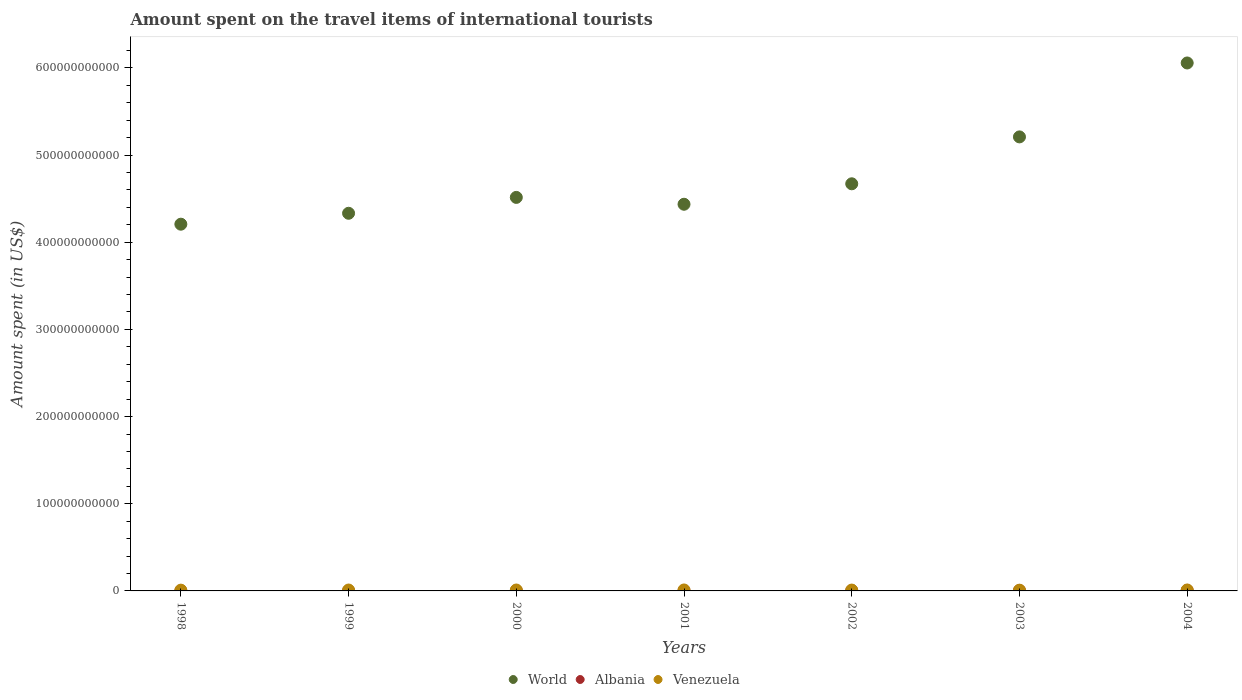Is the number of dotlines equal to the number of legend labels?
Your answer should be compact. Yes. What is the amount spent on the travel items of international tourists in Venezuela in 2000?
Provide a succinct answer. 1.06e+09. Across all years, what is the maximum amount spent on the travel items of international tourists in Venezuela?
Provide a succinct answer. 1.11e+09. Across all years, what is the minimum amount spent on the travel items of international tourists in Venezuela?
Provide a short and direct response. 8.59e+08. In which year was the amount spent on the travel items of international tourists in Venezuela minimum?
Your answer should be very brief. 2003. What is the total amount spent on the travel items of international tourists in World in the graph?
Provide a short and direct response. 3.34e+12. What is the difference between the amount spent on the travel items of international tourists in Albania in 1998 and that in 2001?
Give a very brief answer. -2.52e+08. What is the difference between the amount spent on the travel items of international tourists in Albania in 1998 and the amount spent on the travel items of international tourists in World in 2004?
Make the answer very short. -6.06e+11. What is the average amount spent on the travel items of international tourists in World per year?
Ensure brevity in your answer.  4.77e+11. In the year 2003, what is the difference between the amount spent on the travel items of international tourists in Albania and amount spent on the travel items of international tourists in Venezuela?
Your answer should be very brief. -3.70e+08. In how many years, is the amount spent on the travel items of international tourists in Albania greater than 60000000000 US$?
Make the answer very short. 0. What is the ratio of the amount spent on the travel items of international tourists in Albania in 2003 to that in 2004?
Provide a succinct answer. 0.76. Is the amount spent on the travel items of international tourists in Venezuela in 1999 less than that in 2004?
Your answer should be very brief. Yes. What is the difference between the highest and the second highest amount spent on the travel items of international tourists in World?
Your answer should be very brief. 8.48e+1. What is the difference between the highest and the lowest amount spent on the travel items of international tourists in World?
Ensure brevity in your answer.  1.85e+11. Is it the case that in every year, the sum of the amount spent on the travel items of international tourists in World and amount spent on the travel items of international tourists in Venezuela  is greater than the amount spent on the travel items of international tourists in Albania?
Make the answer very short. Yes. Is the amount spent on the travel items of international tourists in World strictly greater than the amount spent on the travel items of international tourists in Venezuela over the years?
Offer a very short reply. Yes. How many dotlines are there?
Keep it short and to the point. 3. How many years are there in the graph?
Provide a succinct answer. 7. What is the difference between two consecutive major ticks on the Y-axis?
Your answer should be compact. 1.00e+11. Are the values on the major ticks of Y-axis written in scientific E-notation?
Offer a very short reply. No. How many legend labels are there?
Offer a terse response. 3. How are the legend labels stacked?
Offer a very short reply. Horizontal. What is the title of the graph?
Offer a terse response. Amount spent on the travel items of international tourists. Does "Thailand" appear as one of the legend labels in the graph?
Offer a terse response. No. What is the label or title of the X-axis?
Your answer should be compact. Years. What is the label or title of the Y-axis?
Ensure brevity in your answer.  Amount spent (in US$). What is the Amount spent (in US$) in World in 1998?
Provide a succinct answer. 4.21e+11. What is the Amount spent (in US$) in Albania in 1998?
Keep it short and to the point. 5.00e+06. What is the Amount spent (in US$) in Venezuela in 1998?
Keep it short and to the point. 8.91e+08. What is the Amount spent (in US$) in World in 1999?
Keep it short and to the point. 4.33e+11. What is the Amount spent (in US$) in Venezuela in 1999?
Provide a short and direct response. 1.04e+09. What is the Amount spent (in US$) in World in 2000?
Ensure brevity in your answer.  4.51e+11. What is the Amount spent (in US$) of Albania in 2000?
Your answer should be compact. 2.72e+08. What is the Amount spent (in US$) of Venezuela in 2000?
Provide a short and direct response. 1.06e+09. What is the Amount spent (in US$) of World in 2001?
Ensure brevity in your answer.  4.44e+11. What is the Amount spent (in US$) in Albania in 2001?
Keep it short and to the point. 2.57e+08. What is the Amount spent (in US$) of Venezuela in 2001?
Make the answer very short. 1.11e+09. What is the Amount spent (in US$) of World in 2002?
Offer a very short reply. 4.67e+11. What is the Amount spent (in US$) of Albania in 2002?
Make the answer very short. 3.65e+08. What is the Amount spent (in US$) of Venezuela in 2002?
Keep it short and to the point. 9.81e+08. What is the Amount spent (in US$) of World in 2003?
Provide a succinct answer. 5.21e+11. What is the Amount spent (in US$) in Albania in 2003?
Provide a short and direct response. 4.89e+08. What is the Amount spent (in US$) of Venezuela in 2003?
Ensure brevity in your answer.  8.59e+08. What is the Amount spent (in US$) in World in 2004?
Give a very brief answer. 6.06e+11. What is the Amount spent (in US$) in Albania in 2004?
Give a very brief answer. 6.42e+08. What is the Amount spent (in US$) in Venezuela in 2004?
Offer a terse response. 1.08e+09. Across all years, what is the maximum Amount spent (in US$) in World?
Offer a terse response. 6.06e+11. Across all years, what is the maximum Amount spent (in US$) in Albania?
Your answer should be very brief. 6.42e+08. Across all years, what is the maximum Amount spent (in US$) of Venezuela?
Offer a very short reply. 1.11e+09. Across all years, what is the minimum Amount spent (in US$) of World?
Offer a very short reply. 4.21e+11. Across all years, what is the minimum Amount spent (in US$) in Venezuela?
Make the answer very short. 8.59e+08. What is the total Amount spent (in US$) of World in the graph?
Provide a succinct answer. 3.34e+12. What is the total Amount spent (in US$) of Albania in the graph?
Keep it short and to the point. 2.04e+09. What is the total Amount spent (in US$) of Venezuela in the graph?
Give a very brief answer. 7.01e+09. What is the difference between the Amount spent (in US$) in World in 1998 and that in 1999?
Provide a succinct answer. -1.25e+1. What is the difference between the Amount spent (in US$) of Albania in 1998 and that in 1999?
Provide a succinct answer. -7.00e+06. What is the difference between the Amount spent (in US$) in Venezuela in 1998 and that in 1999?
Provide a succinct answer. -1.48e+08. What is the difference between the Amount spent (in US$) of World in 1998 and that in 2000?
Give a very brief answer. -3.07e+1. What is the difference between the Amount spent (in US$) of Albania in 1998 and that in 2000?
Your answer should be compact. -2.67e+08. What is the difference between the Amount spent (in US$) in Venezuela in 1998 and that in 2000?
Give a very brief answer. -1.67e+08. What is the difference between the Amount spent (in US$) of World in 1998 and that in 2001?
Make the answer very short. -2.29e+1. What is the difference between the Amount spent (in US$) of Albania in 1998 and that in 2001?
Give a very brief answer. -2.52e+08. What is the difference between the Amount spent (in US$) of Venezuela in 1998 and that in 2001?
Offer a very short reply. -2.17e+08. What is the difference between the Amount spent (in US$) in World in 1998 and that in 2002?
Keep it short and to the point. -4.63e+1. What is the difference between the Amount spent (in US$) of Albania in 1998 and that in 2002?
Your answer should be very brief. -3.60e+08. What is the difference between the Amount spent (in US$) in Venezuela in 1998 and that in 2002?
Your answer should be compact. -9.00e+07. What is the difference between the Amount spent (in US$) of World in 1998 and that in 2003?
Make the answer very short. -1.00e+11. What is the difference between the Amount spent (in US$) of Albania in 1998 and that in 2003?
Your answer should be very brief. -4.84e+08. What is the difference between the Amount spent (in US$) in Venezuela in 1998 and that in 2003?
Give a very brief answer. 3.20e+07. What is the difference between the Amount spent (in US$) of World in 1998 and that in 2004?
Offer a terse response. -1.85e+11. What is the difference between the Amount spent (in US$) in Albania in 1998 and that in 2004?
Your answer should be very brief. -6.37e+08. What is the difference between the Amount spent (in US$) in Venezuela in 1998 and that in 2004?
Your answer should be very brief. -1.86e+08. What is the difference between the Amount spent (in US$) in World in 1999 and that in 2000?
Provide a succinct answer. -1.82e+1. What is the difference between the Amount spent (in US$) of Albania in 1999 and that in 2000?
Give a very brief answer. -2.60e+08. What is the difference between the Amount spent (in US$) in Venezuela in 1999 and that in 2000?
Your answer should be compact. -1.90e+07. What is the difference between the Amount spent (in US$) in World in 1999 and that in 2001?
Keep it short and to the point. -1.04e+1. What is the difference between the Amount spent (in US$) of Albania in 1999 and that in 2001?
Your answer should be compact. -2.45e+08. What is the difference between the Amount spent (in US$) of Venezuela in 1999 and that in 2001?
Provide a succinct answer. -6.90e+07. What is the difference between the Amount spent (in US$) in World in 1999 and that in 2002?
Make the answer very short. -3.38e+1. What is the difference between the Amount spent (in US$) in Albania in 1999 and that in 2002?
Provide a short and direct response. -3.53e+08. What is the difference between the Amount spent (in US$) in Venezuela in 1999 and that in 2002?
Provide a succinct answer. 5.80e+07. What is the difference between the Amount spent (in US$) of World in 1999 and that in 2003?
Your answer should be very brief. -8.76e+1. What is the difference between the Amount spent (in US$) in Albania in 1999 and that in 2003?
Offer a very short reply. -4.77e+08. What is the difference between the Amount spent (in US$) in Venezuela in 1999 and that in 2003?
Your answer should be very brief. 1.80e+08. What is the difference between the Amount spent (in US$) of World in 1999 and that in 2004?
Your response must be concise. -1.72e+11. What is the difference between the Amount spent (in US$) of Albania in 1999 and that in 2004?
Offer a very short reply. -6.30e+08. What is the difference between the Amount spent (in US$) in Venezuela in 1999 and that in 2004?
Your answer should be very brief. -3.80e+07. What is the difference between the Amount spent (in US$) in World in 2000 and that in 2001?
Your response must be concise. 7.86e+09. What is the difference between the Amount spent (in US$) in Albania in 2000 and that in 2001?
Your response must be concise. 1.50e+07. What is the difference between the Amount spent (in US$) in Venezuela in 2000 and that in 2001?
Keep it short and to the point. -5.00e+07. What is the difference between the Amount spent (in US$) in World in 2000 and that in 2002?
Your response must be concise. -1.56e+1. What is the difference between the Amount spent (in US$) in Albania in 2000 and that in 2002?
Offer a terse response. -9.30e+07. What is the difference between the Amount spent (in US$) in Venezuela in 2000 and that in 2002?
Give a very brief answer. 7.70e+07. What is the difference between the Amount spent (in US$) of World in 2000 and that in 2003?
Ensure brevity in your answer.  -6.94e+1. What is the difference between the Amount spent (in US$) in Albania in 2000 and that in 2003?
Make the answer very short. -2.17e+08. What is the difference between the Amount spent (in US$) of Venezuela in 2000 and that in 2003?
Offer a very short reply. 1.99e+08. What is the difference between the Amount spent (in US$) in World in 2000 and that in 2004?
Make the answer very short. -1.54e+11. What is the difference between the Amount spent (in US$) in Albania in 2000 and that in 2004?
Ensure brevity in your answer.  -3.70e+08. What is the difference between the Amount spent (in US$) of Venezuela in 2000 and that in 2004?
Offer a terse response. -1.90e+07. What is the difference between the Amount spent (in US$) of World in 2001 and that in 2002?
Keep it short and to the point. -2.35e+1. What is the difference between the Amount spent (in US$) of Albania in 2001 and that in 2002?
Keep it short and to the point. -1.08e+08. What is the difference between the Amount spent (in US$) in Venezuela in 2001 and that in 2002?
Provide a succinct answer. 1.27e+08. What is the difference between the Amount spent (in US$) in World in 2001 and that in 2003?
Your answer should be compact. -7.73e+1. What is the difference between the Amount spent (in US$) of Albania in 2001 and that in 2003?
Your answer should be very brief. -2.32e+08. What is the difference between the Amount spent (in US$) of Venezuela in 2001 and that in 2003?
Make the answer very short. 2.49e+08. What is the difference between the Amount spent (in US$) in World in 2001 and that in 2004?
Give a very brief answer. -1.62e+11. What is the difference between the Amount spent (in US$) of Albania in 2001 and that in 2004?
Offer a terse response. -3.85e+08. What is the difference between the Amount spent (in US$) of Venezuela in 2001 and that in 2004?
Your answer should be compact. 3.10e+07. What is the difference between the Amount spent (in US$) of World in 2002 and that in 2003?
Your response must be concise. -5.38e+1. What is the difference between the Amount spent (in US$) in Albania in 2002 and that in 2003?
Keep it short and to the point. -1.24e+08. What is the difference between the Amount spent (in US$) of Venezuela in 2002 and that in 2003?
Keep it short and to the point. 1.22e+08. What is the difference between the Amount spent (in US$) in World in 2002 and that in 2004?
Offer a very short reply. -1.39e+11. What is the difference between the Amount spent (in US$) of Albania in 2002 and that in 2004?
Provide a short and direct response. -2.77e+08. What is the difference between the Amount spent (in US$) of Venezuela in 2002 and that in 2004?
Keep it short and to the point. -9.60e+07. What is the difference between the Amount spent (in US$) in World in 2003 and that in 2004?
Provide a short and direct response. -8.48e+1. What is the difference between the Amount spent (in US$) of Albania in 2003 and that in 2004?
Give a very brief answer. -1.53e+08. What is the difference between the Amount spent (in US$) of Venezuela in 2003 and that in 2004?
Provide a short and direct response. -2.18e+08. What is the difference between the Amount spent (in US$) in World in 1998 and the Amount spent (in US$) in Albania in 1999?
Keep it short and to the point. 4.21e+11. What is the difference between the Amount spent (in US$) of World in 1998 and the Amount spent (in US$) of Venezuela in 1999?
Offer a terse response. 4.20e+11. What is the difference between the Amount spent (in US$) in Albania in 1998 and the Amount spent (in US$) in Venezuela in 1999?
Your response must be concise. -1.03e+09. What is the difference between the Amount spent (in US$) in World in 1998 and the Amount spent (in US$) in Albania in 2000?
Give a very brief answer. 4.20e+11. What is the difference between the Amount spent (in US$) of World in 1998 and the Amount spent (in US$) of Venezuela in 2000?
Provide a short and direct response. 4.20e+11. What is the difference between the Amount spent (in US$) of Albania in 1998 and the Amount spent (in US$) of Venezuela in 2000?
Make the answer very short. -1.05e+09. What is the difference between the Amount spent (in US$) in World in 1998 and the Amount spent (in US$) in Albania in 2001?
Your answer should be very brief. 4.20e+11. What is the difference between the Amount spent (in US$) of World in 1998 and the Amount spent (in US$) of Venezuela in 2001?
Ensure brevity in your answer.  4.20e+11. What is the difference between the Amount spent (in US$) in Albania in 1998 and the Amount spent (in US$) in Venezuela in 2001?
Give a very brief answer. -1.10e+09. What is the difference between the Amount spent (in US$) of World in 1998 and the Amount spent (in US$) of Albania in 2002?
Ensure brevity in your answer.  4.20e+11. What is the difference between the Amount spent (in US$) in World in 1998 and the Amount spent (in US$) in Venezuela in 2002?
Give a very brief answer. 4.20e+11. What is the difference between the Amount spent (in US$) in Albania in 1998 and the Amount spent (in US$) in Venezuela in 2002?
Provide a short and direct response. -9.76e+08. What is the difference between the Amount spent (in US$) of World in 1998 and the Amount spent (in US$) of Albania in 2003?
Make the answer very short. 4.20e+11. What is the difference between the Amount spent (in US$) in World in 1998 and the Amount spent (in US$) in Venezuela in 2003?
Offer a terse response. 4.20e+11. What is the difference between the Amount spent (in US$) of Albania in 1998 and the Amount spent (in US$) of Venezuela in 2003?
Give a very brief answer. -8.54e+08. What is the difference between the Amount spent (in US$) in World in 1998 and the Amount spent (in US$) in Albania in 2004?
Your answer should be very brief. 4.20e+11. What is the difference between the Amount spent (in US$) of World in 1998 and the Amount spent (in US$) of Venezuela in 2004?
Offer a terse response. 4.20e+11. What is the difference between the Amount spent (in US$) of Albania in 1998 and the Amount spent (in US$) of Venezuela in 2004?
Your response must be concise. -1.07e+09. What is the difference between the Amount spent (in US$) in World in 1999 and the Amount spent (in US$) in Albania in 2000?
Give a very brief answer. 4.33e+11. What is the difference between the Amount spent (in US$) of World in 1999 and the Amount spent (in US$) of Venezuela in 2000?
Your answer should be compact. 4.32e+11. What is the difference between the Amount spent (in US$) of Albania in 1999 and the Amount spent (in US$) of Venezuela in 2000?
Your answer should be compact. -1.05e+09. What is the difference between the Amount spent (in US$) in World in 1999 and the Amount spent (in US$) in Albania in 2001?
Provide a succinct answer. 4.33e+11. What is the difference between the Amount spent (in US$) of World in 1999 and the Amount spent (in US$) of Venezuela in 2001?
Provide a succinct answer. 4.32e+11. What is the difference between the Amount spent (in US$) of Albania in 1999 and the Amount spent (in US$) of Venezuela in 2001?
Make the answer very short. -1.10e+09. What is the difference between the Amount spent (in US$) in World in 1999 and the Amount spent (in US$) in Albania in 2002?
Your answer should be very brief. 4.33e+11. What is the difference between the Amount spent (in US$) in World in 1999 and the Amount spent (in US$) in Venezuela in 2002?
Offer a very short reply. 4.32e+11. What is the difference between the Amount spent (in US$) of Albania in 1999 and the Amount spent (in US$) of Venezuela in 2002?
Offer a very short reply. -9.69e+08. What is the difference between the Amount spent (in US$) of World in 1999 and the Amount spent (in US$) of Albania in 2003?
Make the answer very short. 4.33e+11. What is the difference between the Amount spent (in US$) of World in 1999 and the Amount spent (in US$) of Venezuela in 2003?
Provide a succinct answer. 4.32e+11. What is the difference between the Amount spent (in US$) in Albania in 1999 and the Amount spent (in US$) in Venezuela in 2003?
Make the answer very short. -8.47e+08. What is the difference between the Amount spent (in US$) of World in 1999 and the Amount spent (in US$) of Albania in 2004?
Your answer should be compact. 4.33e+11. What is the difference between the Amount spent (in US$) of World in 1999 and the Amount spent (in US$) of Venezuela in 2004?
Offer a very short reply. 4.32e+11. What is the difference between the Amount spent (in US$) in Albania in 1999 and the Amount spent (in US$) in Venezuela in 2004?
Offer a very short reply. -1.06e+09. What is the difference between the Amount spent (in US$) in World in 2000 and the Amount spent (in US$) in Albania in 2001?
Keep it short and to the point. 4.51e+11. What is the difference between the Amount spent (in US$) of World in 2000 and the Amount spent (in US$) of Venezuela in 2001?
Offer a terse response. 4.50e+11. What is the difference between the Amount spent (in US$) of Albania in 2000 and the Amount spent (in US$) of Venezuela in 2001?
Make the answer very short. -8.36e+08. What is the difference between the Amount spent (in US$) in World in 2000 and the Amount spent (in US$) in Albania in 2002?
Your answer should be compact. 4.51e+11. What is the difference between the Amount spent (in US$) of World in 2000 and the Amount spent (in US$) of Venezuela in 2002?
Your answer should be very brief. 4.50e+11. What is the difference between the Amount spent (in US$) of Albania in 2000 and the Amount spent (in US$) of Venezuela in 2002?
Provide a succinct answer. -7.09e+08. What is the difference between the Amount spent (in US$) in World in 2000 and the Amount spent (in US$) in Albania in 2003?
Offer a very short reply. 4.51e+11. What is the difference between the Amount spent (in US$) in World in 2000 and the Amount spent (in US$) in Venezuela in 2003?
Give a very brief answer. 4.51e+11. What is the difference between the Amount spent (in US$) of Albania in 2000 and the Amount spent (in US$) of Venezuela in 2003?
Provide a succinct answer. -5.87e+08. What is the difference between the Amount spent (in US$) in World in 2000 and the Amount spent (in US$) in Albania in 2004?
Offer a terse response. 4.51e+11. What is the difference between the Amount spent (in US$) of World in 2000 and the Amount spent (in US$) of Venezuela in 2004?
Provide a succinct answer. 4.50e+11. What is the difference between the Amount spent (in US$) in Albania in 2000 and the Amount spent (in US$) in Venezuela in 2004?
Offer a terse response. -8.05e+08. What is the difference between the Amount spent (in US$) in World in 2001 and the Amount spent (in US$) in Albania in 2002?
Your response must be concise. 4.43e+11. What is the difference between the Amount spent (in US$) of World in 2001 and the Amount spent (in US$) of Venezuela in 2002?
Your answer should be compact. 4.43e+11. What is the difference between the Amount spent (in US$) of Albania in 2001 and the Amount spent (in US$) of Venezuela in 2002?
Provide a succinct answer. -7.24e+08. What is the difference between the Amount spent (in US$) in World in 2001 and the Amount spent (in US$) in Albania in 2003?
Make the answer very short. 4.43e+11. What is the difference between the Amount spent (in US$) of World in 2001 and the Amount spent (in US$) of Venezuela in 2003?
Your answer should be compact. 4.43e+11. What is the difference between the Amount spent (in US$) of Albania in 2001 and the Amount spent (in US$) of Venezuela in 2003?
Your answer should be very brief. -6.02e+08. What is the difference between the Amount spent (in US$) of World in 2001 and the Amount spent (in US$) of Albania in 2004?
Your answer should be compact. 4.43e+11. What is the difference between the Amount spent (in US$) in World in 2001 and the Amount spent (in US$) in Venezuela in 2004?
Your answer should be compact. 4.42e+11. What is the difference between the Amount spent (in US$) in Albania in 2001 and the Amount spent (in US$) in Venezuela in 2004?
Give a very brief answer. -8.20e+08. What is the difference between the Amount spent (in US$) of World in 2002 and the Amount spent (in US$) of Albania in 2003?
Give a very brief answer. 4.67e+11. What is the difference between the Amount spent (in US$) of World in 2002 and the Amount spent (in US$) of Venezuela in 2003?
Give a very brief answer. 4.66e+11. What is the difference between the Amount spent (in US$) of Albania in 2002 and the Amount spent (in US$) of Venezuela in 2003?
Your answer should be very brief. -4.94e+08. What is the difference between the Amount spent (in US$) of World in 2002 and the Amount spent (in US$) of Albania in 2004?
Provide a succinct answer. 4.66e+11. What is the difference between the Amount spent (in US$) in World in 2002 and the Amount spent (in US$) in Venezuela in 2004?
Ensure brevity in your answer.  4.66e+11. What is the difference between the Amount spent (in US$) of Albania in 2002 and the Amount spent (in US$) of Venezuela in 2004?
Keep it short and to the point. -7.12e+08. What is the difference between the Amount spent (in US$) in World in 2003 and the Amount spent (in US$) in Albania in 2004?
Offer a terse response. 5.20e+11. What is the difference between the Amount spent (in US$) in World in 2003 and the Amount spent (in US$) in Venezuela in 2004?
Your response must be concise. 5.20e+11. What is the difference between the Amount spent (in US$) of Albania in 2003 and the Amount spent (in US$) of Venezuela in 2004?
Offer a terse response. -5.88e+08. What is the average Amount spent (in US$) of World per year?
Your answer should be compact. 4.77e+11. What is the average Amount spent (in US$) of Albania per year?
Provide a succinct answer. 2.92e+08. What is the average Amount spent (in US$) in Venezuela per year?
Provide a short and direct response. 1.00e+09. In the year 1998, what is the difference between the Amount spent (in US$) of World and Amount spent (in US$) of Albania?
Your response must be concise. 4.21e+11. In the year 1998, what is the difference between the Amount spent (in US$) in World and Amount spent (in US$) in Venezuela?
Make the answer very short. 4.20e+11. In the year 1998, what is the difference between the Amount spent (in US$) of Albania and Amount spent (in US$) of Venezuela?
Ensure brevity in your answer.  -8.86e+08. In the year 1999, what is the difference between the Amount spent (in US$) of World and Amount spent (in US$) of Albania?
Offer a very short reply. 4.33e+11. In the year 1999, what is the difference between the Amount spent (in US$) of World and Amount spent (in US$) of Venezuela?
Your answer should be compact. 4.32e+11. In the year 1999, what is the difference between the Amount spent (in US$) of Albania and Amount spent (in US$) of Venezuela?
Ensure brevity in your answer.  -1.03e+09. In the year 2000, what is the difference between the Amount spent (in US$) of World and Amount spent (in US$) of Albania?
Keep it short and to the point. 4.51e+11. In the year 2000, what is the difference between the Amount spent (in US$) of World and Amount spent (in US$) of Venezuela?
Your answer should be very brief. 4.50e+11. In the year 2000, what is the difference between the Amount spent (in US$) in Albania and Amount spent (in US$) in Venezuela?
Provide a succinct answer. -7.86e+08. In the year 2001, what is the difference between the Amount spent (in US$) of World and Amount spent (in US$) of Albania?
Offer a very short reply. 4.43e+11. In the year 2001, what is the difference between the Amount spent (in US$) of World and Amount spent (in US$) of Venezuela?
Your answer should be very brief. 4.42e+11. In the year 2001, what is the difference between the Amount spent (in US$) of Albania and Amount spent (in US$) of Venezuela?
Offer a very short reply. -8.51e+08. In the year 2002, what is the difference between the Amount spent (in US$) in World and Amount spent (in US$) in Albania?
Offer a very short reply. 4.67e+11. In the year 2002, what is the difference between the Amount spent (in US$) of World and Amount spent (in US$) of Venezuela?
Your answer should be very brief. 4.66e+11. In the year 2002, what is the difference between the Amount spent (in US$) of Albania and Amount spent (in US$) of Venezuela?
Provide a succinct answer. -6.16e+08. In the year 2003, what is the difference between the Amount spent (in US$) in World and Amount spent (in US$) in Albania?
Make the answer very short. 5.20e+11. In the year 2003, what is the difference between the Amount spent (in US$) in World and Amount spent (in US$) in Venezuela?
Provide a succinct answer. 5.20e+11. In the year 2003, what is the difference between the Amount spent (in US$) of Albania and Amount spent (in US$) of Venezuela?
Give a very brief answer. -3.70e+08. In the year 2004, what is the difference between the Amount spent (in US$) in World and Amount spent (in US$) in Albania?
Your response must be concise. 6.05e+11. In the year 2004, what is the difference between the Amount spent (in US$) of World and Amount spent (in US$) of Venezuela?
Your answer should be compact. 6.05e+11. In the year 2004, what is the difference between the Amount spent (in US$) of Albania and Amount spent (in US$) of Venezuela?
Provide a succinct answer. -4.35e+08. What is the ratio of the Amount spent (in US$) in World in 1998 to that in 1999?
Your response must be concise. 0.97. What is the ratio of the Amount spent (in US$) in Albania in 1998 to that in 1999?
Your response must be concise. 0.42. What is the ratio of the Amount spent (in US$) of Venezuela in 1998 to that in 1999?
Offer a terse response. 0.86. What is the ratio of the Amount spent (in US$) in World in 1998 to that in 2000?
Offer a very short reply. 0.93. What is the ratio of the Amount spent (in US$) of Albania in 1998 to that in 2000?
Provide a succinct answer. 0.02. What is the ratio of the Amount spent (in US$) in Venezuela in 1998 to that in 2000?
Ensure brevity in your answer.  0.84. What is the ratio of the Amount spent (in US$) of World in 1998 to that in 2001?
Offer a terse response. 0.95. What is the ratio of the Amount spent (in US$) in Albania in 1998 to that in 2001?
Offer a terse response. 0.02. What is the ratio of the Amount spent (in US$) of Venezuela in 1998 to that in 2001?
Keep it short and to the point. 0.8. What is the ratio of the Amount spent (in US$) of World in 1998 to that in 2002?
Offer a very short reply. 0.9. What is the ratio of the Amount spent (in US$) of Albania in 1998 to that in 2002?
Offer a terse response. 0.01. What is the ratio of the Amount spent (in US$) of Venezuela in 1998 to that in 2002?
Your response must be concise. 0.91. What is the ratio of the Amount spent (in US$) in World in 1998 to that in 2003?
Offer a terse response. 0.81. What is the ratio of the Amount spent (in US$) of Albania in 1998 to that in 2003?
Your answer should be very brief. 0.01. What is the ratio of the Amount spent (in US$) in Venezuela in 1998 to that in 2003?
Your response must be concise. 1.04. What is the ratio of the Amount spent (in US$) of World in 1998 to that in 2004?
Provide a short and direct response. 0.69. What is the ratio of the Amount spent (in US$) of Albania in 1998 to that in 2004?
Offer a terse response. 0.01. What is the ratio of the Amount spent (in US$) in Venezuela in 1998 to that in 2004?
Make the answer very short. 0.83. What is the ratio of the Amount spent (in US$) of World in 1999 to that in 2000?
Make the answer very short. 0.96. What is the ratio of the Amount spent (in US$) in Albania in 1999 to that in 2000?
Offer a terse response. 0.04. What is the ratio of the Amount spent (in US$) in Venezuela in 1999 to that in 2000?
Provide a succinct answer. 0.98. What is the ratio of the Amount spent (in US$) in World in 1999 to that in 2001?
Offer a very short reply. 0.98. What is the ratio of the Amount spent (in US$) of Albania in 1999 to that in 2001?
Offer a terse response. 0.05. What is the ratio of the Amount spent (in US$) of Venezuela in 1999 to that in 2001?
Provide a short and direct response. 0.94. What is the ratio of the Amount spent (in US$) of World in 1999 to that in 2002?
Offer a terse response. 0.93. What is the ratio of the Amount spent (in US$) of Albania in 1999 to that in 2002?
Offer a very short reply. 0.03. What is the ratio of the Amount spent (in US$) in Venezuela in 1999 to that in 2002?
Your response must be concise. 1.06. What is the ratio of the Amount spent (in US$) in World in 1999 to that in 2003?
Provide a short and direct response. 0.83. What is the ratio of the Amount spent (in US$) of Albania in 1999 to that in 2003?
Your answer should be compact. 0.02. What is the ratio of the Amount spent (in US$) of Venezuela in 1999 to that in 2003?
Your response must be concise. 1.21. What is the ratio of the Amount spent (in US$) in World in 1999 to that in 2004?
Offer a terse response. 0.72. What is the ratio of the Amount spent (in US$) in Albania in 1999 to that in 2004?
Offer a terse response. 0.02. What is the ratio of the Amount spent (in US$) of Venezuela in 1999 to that in 2004?
Provide a short and direct response. 0.96. What is the ratio of the Amount spent (in US$) in World in 2000 to that in 2001?
Keep it short and to the point. 1.02. What is the ratio of the Amount spent (in US$) in Albania in 2000 to that in 2001?
Provide a succinct answer. 1.06. What is the ratio of the Amount spent (in US$) of Venezuela in 2000 to that in 2001?
Your answer should be very brief. 0.95. What is the ratio of the Amount spent (in US$) in World in 2000 to that in 2002?
Offer a very short reply. 0.97. What is the ratio of the Amount spent (in US$) of Albania in 2000 to that in 2002?
Your response must be concise. 0.75. What is the ratio of the Amount spent (in US$) in Venezuela in 2000 to that in 2002?
Your response must be concise. 1.08. What is the ratio of the Amount spent (in US$) in World in 2000 to that in 2003?
Keep it short and to the point. 0.87. What is the ratio of the Amount spent (in US$) of Albania in 2000 to that in 2003?
Provide a short and direct response. 0.56. What is the ratio of the Amount spent (in US$) of Venezuela in 2000 to that in 2003?
Offer a very short reply. 1.23. What is the ratio of the Amount spent (in US$) of World in 2000 to that in 2004?
Offer a terse response. 0.75. What is the ratio of the Amount spent (in US$) of Albania in 2000 to that in 2004?
Give a very brief answer. 0.42. What is the ratio of the Amount spent (in US$) in Venezuela in 2000 to that in 2004?
Give a very brief answer. 0.98. What is the ratio of the Amount spent (in US$) in World in 2001 to that in 2002?
Make the answer very short. 0.95. What is the ratio of the Amount spent (in US$) in Albania in 2001 to that in 2002?
Give a very brief answer. 0.7. What is the ratio of the Amount spent (in US$) in Venezuela in 2001 to that in 2002?
Make the answer very short. 1.13. What is the ratio of the Amount spent (in US$) in World in 2001 to that in 2003?
Keep it short and to the point. 0.85. What is the ratio of the Amount spent (in US$) in Albania in 2001 to that in 2003?
Provide a succinct answer. 0.53. What is the ratio of the Amount spent (in US$) in Venezuela in 2001 to that in 2003?
Provide a short and direct response. 1.29. What is the ratio of the Amount spent (in US$) in World in 2001 to that in 2004?
Give a very brief answer. 0.73. What is the ratio of the Amount spent (in US$) of Albania in 2001 to that in 2004?
Provide a succinct answer. 0.4. What is the ratio of the Amount spent (in US$) of Venezuela in 2001 to that in 2004?
Your answer should be very brief. 1.03. What is the ratio of the Amount spent (in US$) in World in 2002 to that in 2003?
Your answer should be very brief. 0.9. What is the ratio of the Amount spent (in US$) in Albania in 2002 to that in 2003?
Your response must be concise. 0.75. What is the ratio of the Amount spent (in US$) in Venezuela in 2002 to that in 2003?
Offer a very short reply. 1.14. What is the ratio of the Amount spent (in US$) in World in 2002 to that in 2004?
Keep it short and to the point. 0.77. What is the ratio of the Amount spent (in US$) of Albania in 2002 to that in 2004?
Make the answer very short. 0.57. What is the ratio of the Amount spent (in US$) in Venezuela in 2002 to that in 2004?
Your answer should be very brief. 0.91. What is the ratio of the Amount spent (in US$) in World in 2003 to that in 2004?
Offer a very short reply. 0.86. What is the ratio of the Amount spent (in US$) of Albania in 2003 to that in 2004?
Provide a short and direct response. 0.76. What is the ratio of the Amount spent (in US$) of Venezuela in 2003 to that in 2004?
Your answer should be compact. 0.8. What is the difference between the highest and the second highest Amount spent (in US$) of World?
Offer a very short reply. 8.48e+1. What is the difference between the highest and the second highest Amount spent (in US$) in Albania?
Make the answer very short. 1.53e+08. What is the difference between the highest and the second highest Amount spent (in US$) in Venezuela?
Your response must be concise. 3.10e+07. What is the difference between the highest and the lowest Amount spent (in US$) in World?
Your answer should be compact. 1.85e+11. What is the difference between the highest and the lowest Amount spent (in US$) in Albania?
Make the answer very short. 6.37e+08. What is the difference between the highest and the lowest Amount spent (in US$) of Venezuela?
Keep it short and to the point. 2.49e+08. 